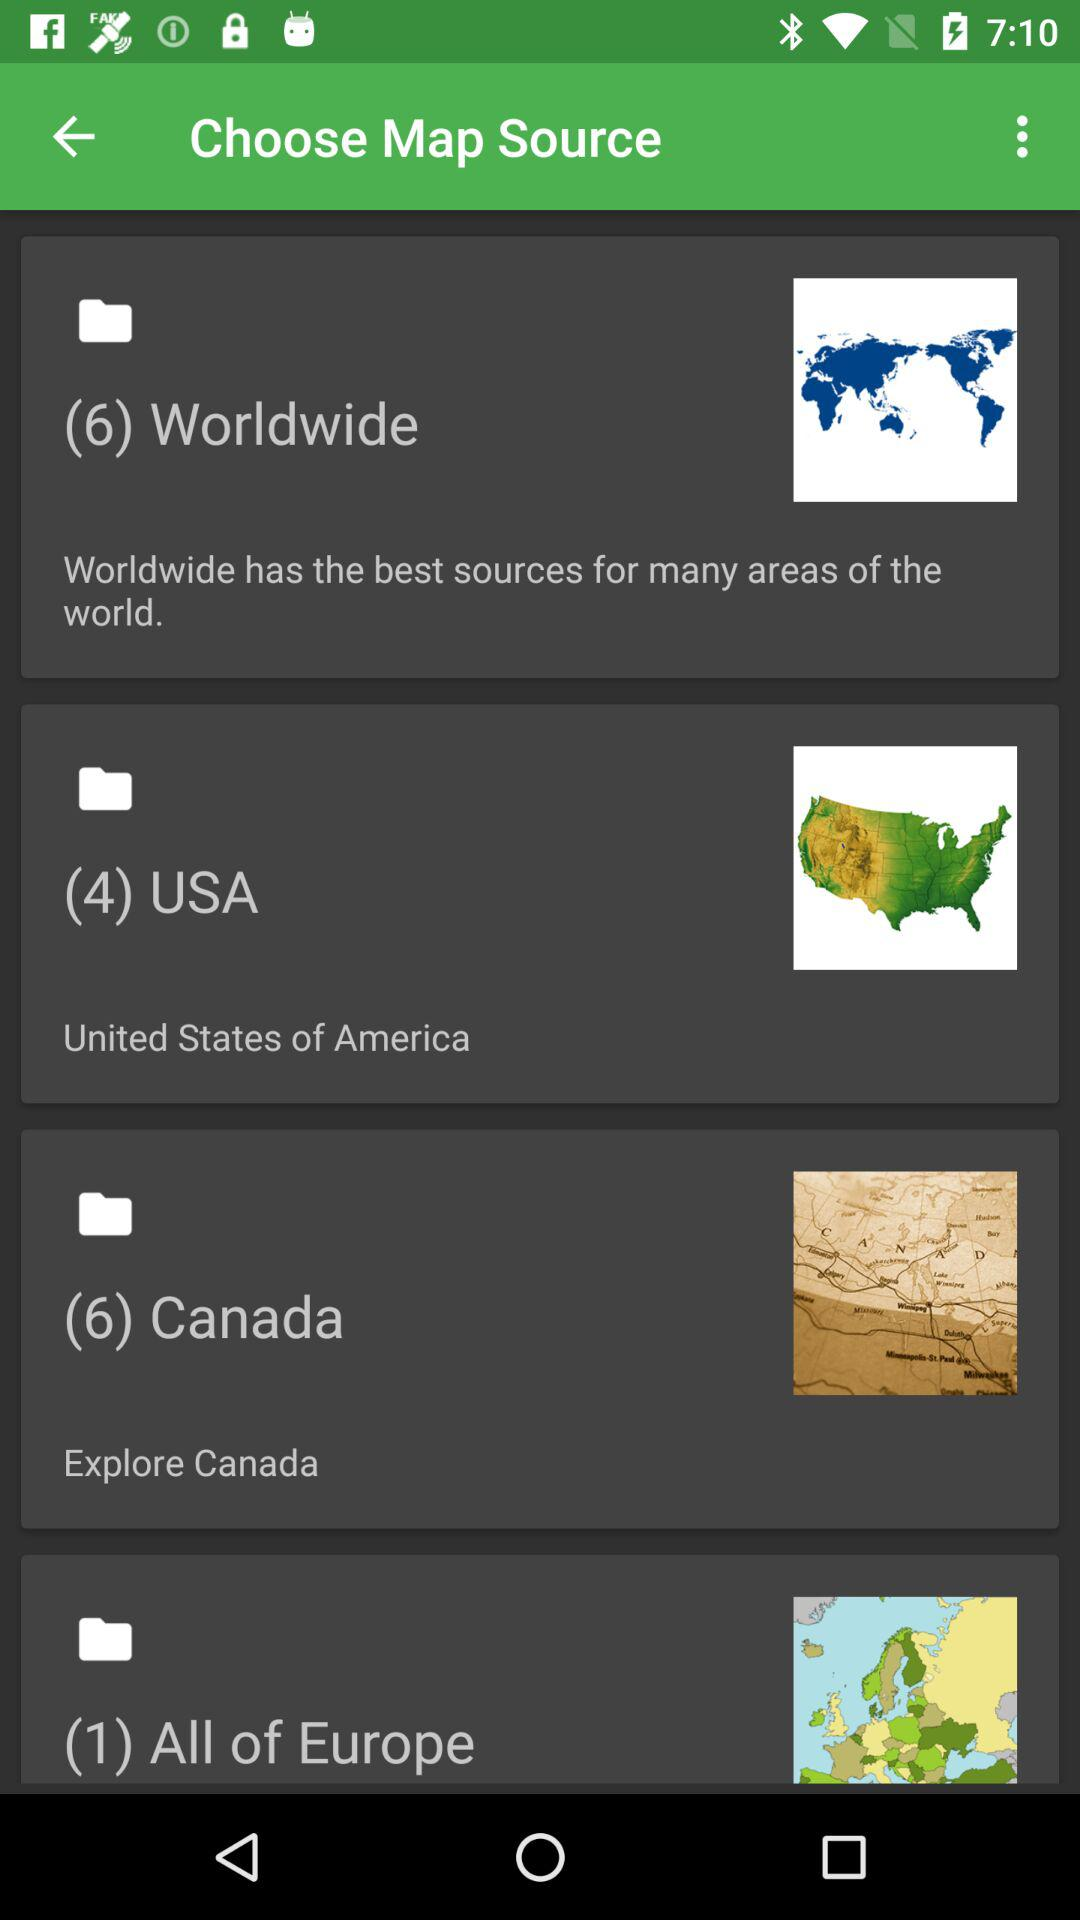How many files are in the "Canada" folder? There are 6 files in the "Canada" folder. 